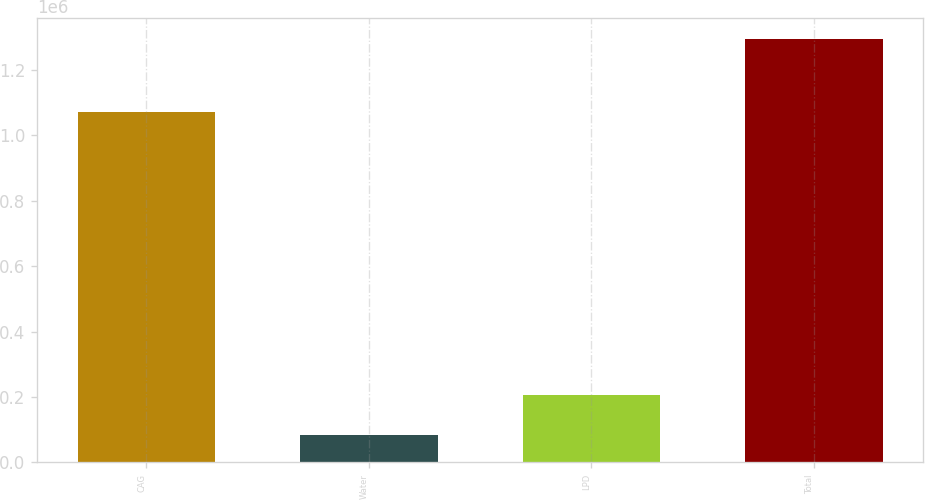<chart> <loc_0><loc_0><loc_500><loc_500><bar_chart><fcel>CAG<fcel>Water<fcel>LPD<fcel>Total<nl><fcel>1.07221e+06<fcel>84680<fcel>205546<fcel>1.29334e+06<nl></chart> 